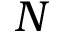Convert formula to latex. <formula><loc_0><loc_0><loc_500><loc_500>N</formula> 